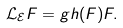<formula> <loc_0><loc_0><loc_500><loc_500>\mathcal { L } _ { \mathcal { E } } F = g h ( F ) F .</formula> 